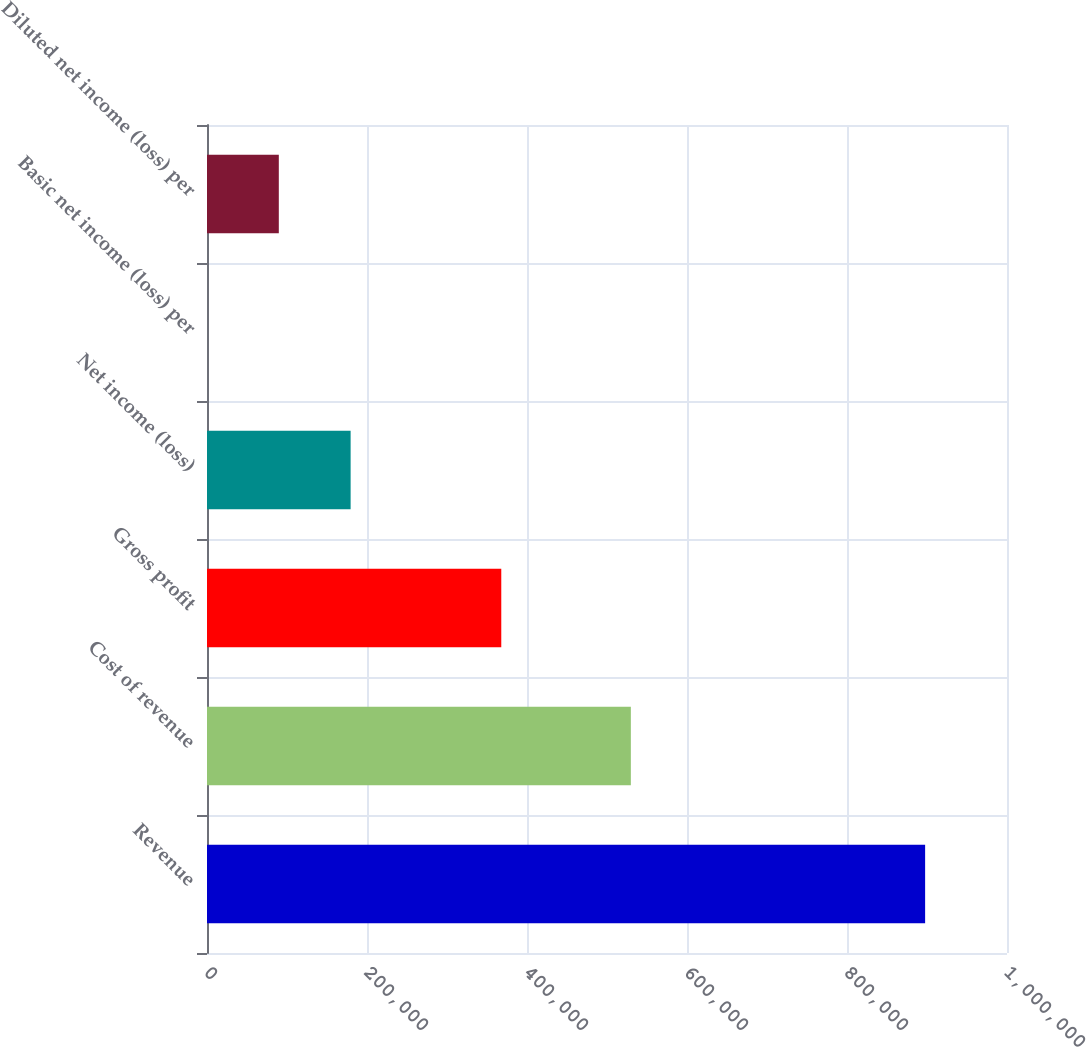<chart> <loc_0><loc_0><loc_500><loc_500><bar_chart><fcel>Revenue<fcel>Cost of revenue<fcel>Gross profit<fcel>Net income (loss)<fcel>Basic net income (loss) per<fcel>Diluted net income (loss) per<nl><fcel>897655<fcel>529812<fcel>367843<fcel>179531<fcel>0.11<fcel>89765.6<nl></chart> 